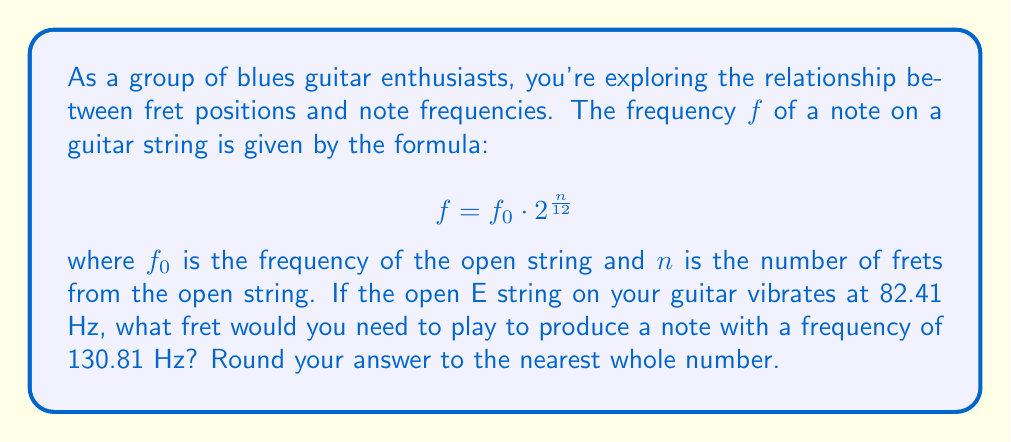What is the answer to this math problem? Let's approach this step-by-step using logarithms:

1) We're given the formula: $f = f_0 \cdot 2^{\frac{n}{12}}$

2) We know:
   $f_0 = 82.41$ Hz (frequency of open E string)
   $f = 130.81$ Hz (frequency we want to achieve)

3) Let's substitute these values into the formula:

   $130.81 = 82.41 \cdot 2^{\frac{n}{12}}$

4) To isolate $n$, we first divide both sides by 82.41:

   $\frac{130.81}{82.41} = 2^{\frac{n}{12}}$

5) Now, we can take the logarithm (base 2) of both sides:

   $\log_2(\frac{130.81}{82.41}) = \log_2(2^{\frac{n}{12}})$

6) Using the logarithm property $\log_a(a^x) = x$, we get:

   $\log_2(\frac{130.81}{82.41}) = \frac{n}{12}$

7) Multiply both sides by 12:

   $12 \cdot \log_2(\frac{130.81}{82.41}) = n$

8) Now we can calculate:

   $n = 12 \cdot \log_2(\frac{130.81}{82.41}) \approx 7.02$

9) Rounding to the nearest whole number:

   $n \approx 7$

Therefore, you would need to play the 7th fret to produce a note with a frequency of 130.81 Hz.
Answer: 7th fret 